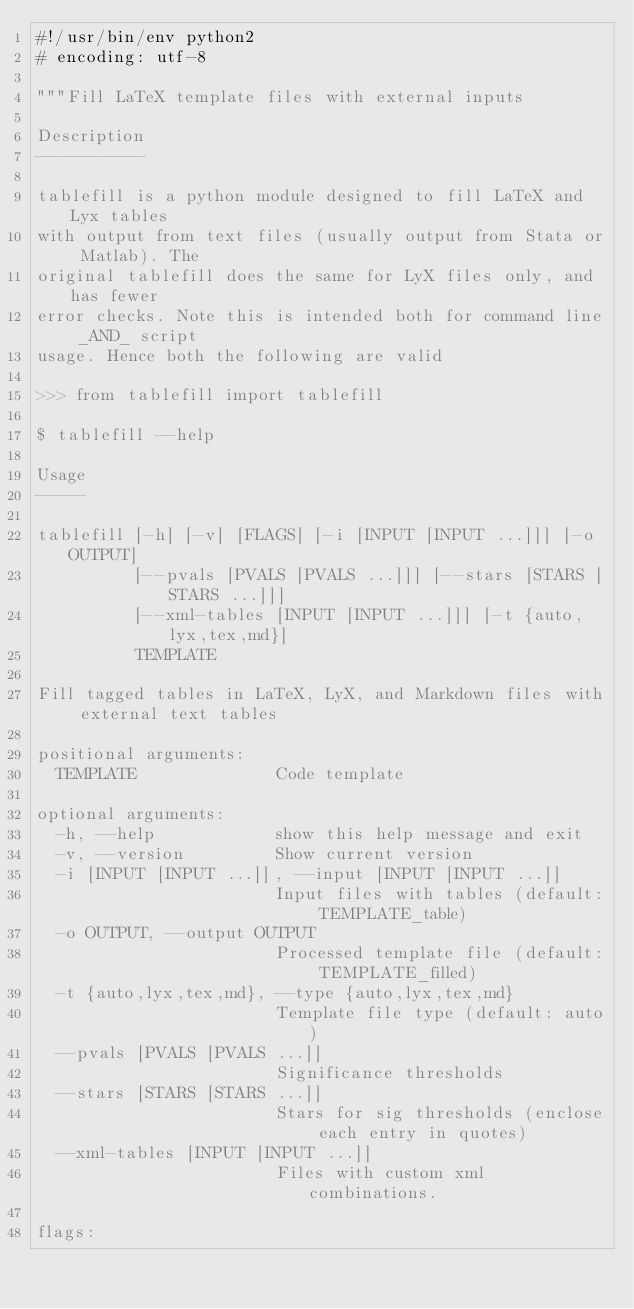Convert code to text. <code><loc_0><loc_0><loc_500><loc_500><_Python_>#!/usr/bin/env python2
# encoding: utf-8

"""Fill LaTeX template files with external inputs

Description
-----------

tablefill is a python module designed to fill LaTeX and Lyx tables
with output from text files (usually output from Stata or Matlab). The
original tablefill does the same for LyX files only, and has fewer
error checks. Note this is intended both for command line _AND_ script
usage. Hence both the following are valid

>>> from tablefill import tablefill

$ tablefill --help

Usage
-----

tablefill [-h] [-v] [FLAGS] [-i [INPUT [INPUT ...]]] [-o OUTPUT]
          [--pvals [PVALS [PVALS ...]]] [--stars [STARS [STARS ...]]]
          [--xml-tables [INPUT [INPUT ...]]] [-t {auto,lyx,tex,md}]
          TEMPLATE

Fill tagged tables in LaTeX, LyX, and Markdown files with external text tables

positional arguments:
  TEMPLATE              Code template

optional arguments:
  -h, --help            show this help message and exit
  -v, --version         Show current version
  -i [INPUT [INPUT ...]], --input [INPUT [INPUT ...]]
                        Input files with tables (default: TEMPLATE_table)
  -o OUTPUT, --output OUTPUT
                        Processed template file (default: TEMPLATE_filled)
  -t {auto,lyx,tex,md}, --type {auto,lyx,tex,md}
                        Template file type (default: auto)
  --pvals [PVALS [PVALS ...]]
                        Significance thresholds
  --stars [STARS [STARS ...]]
                        Stars for sig thresholds (enclose each entry in quotes)
  --xml-tables [INPUT [INPUT ...]]
                        Files with custom xml combinations.

flags:</code> 